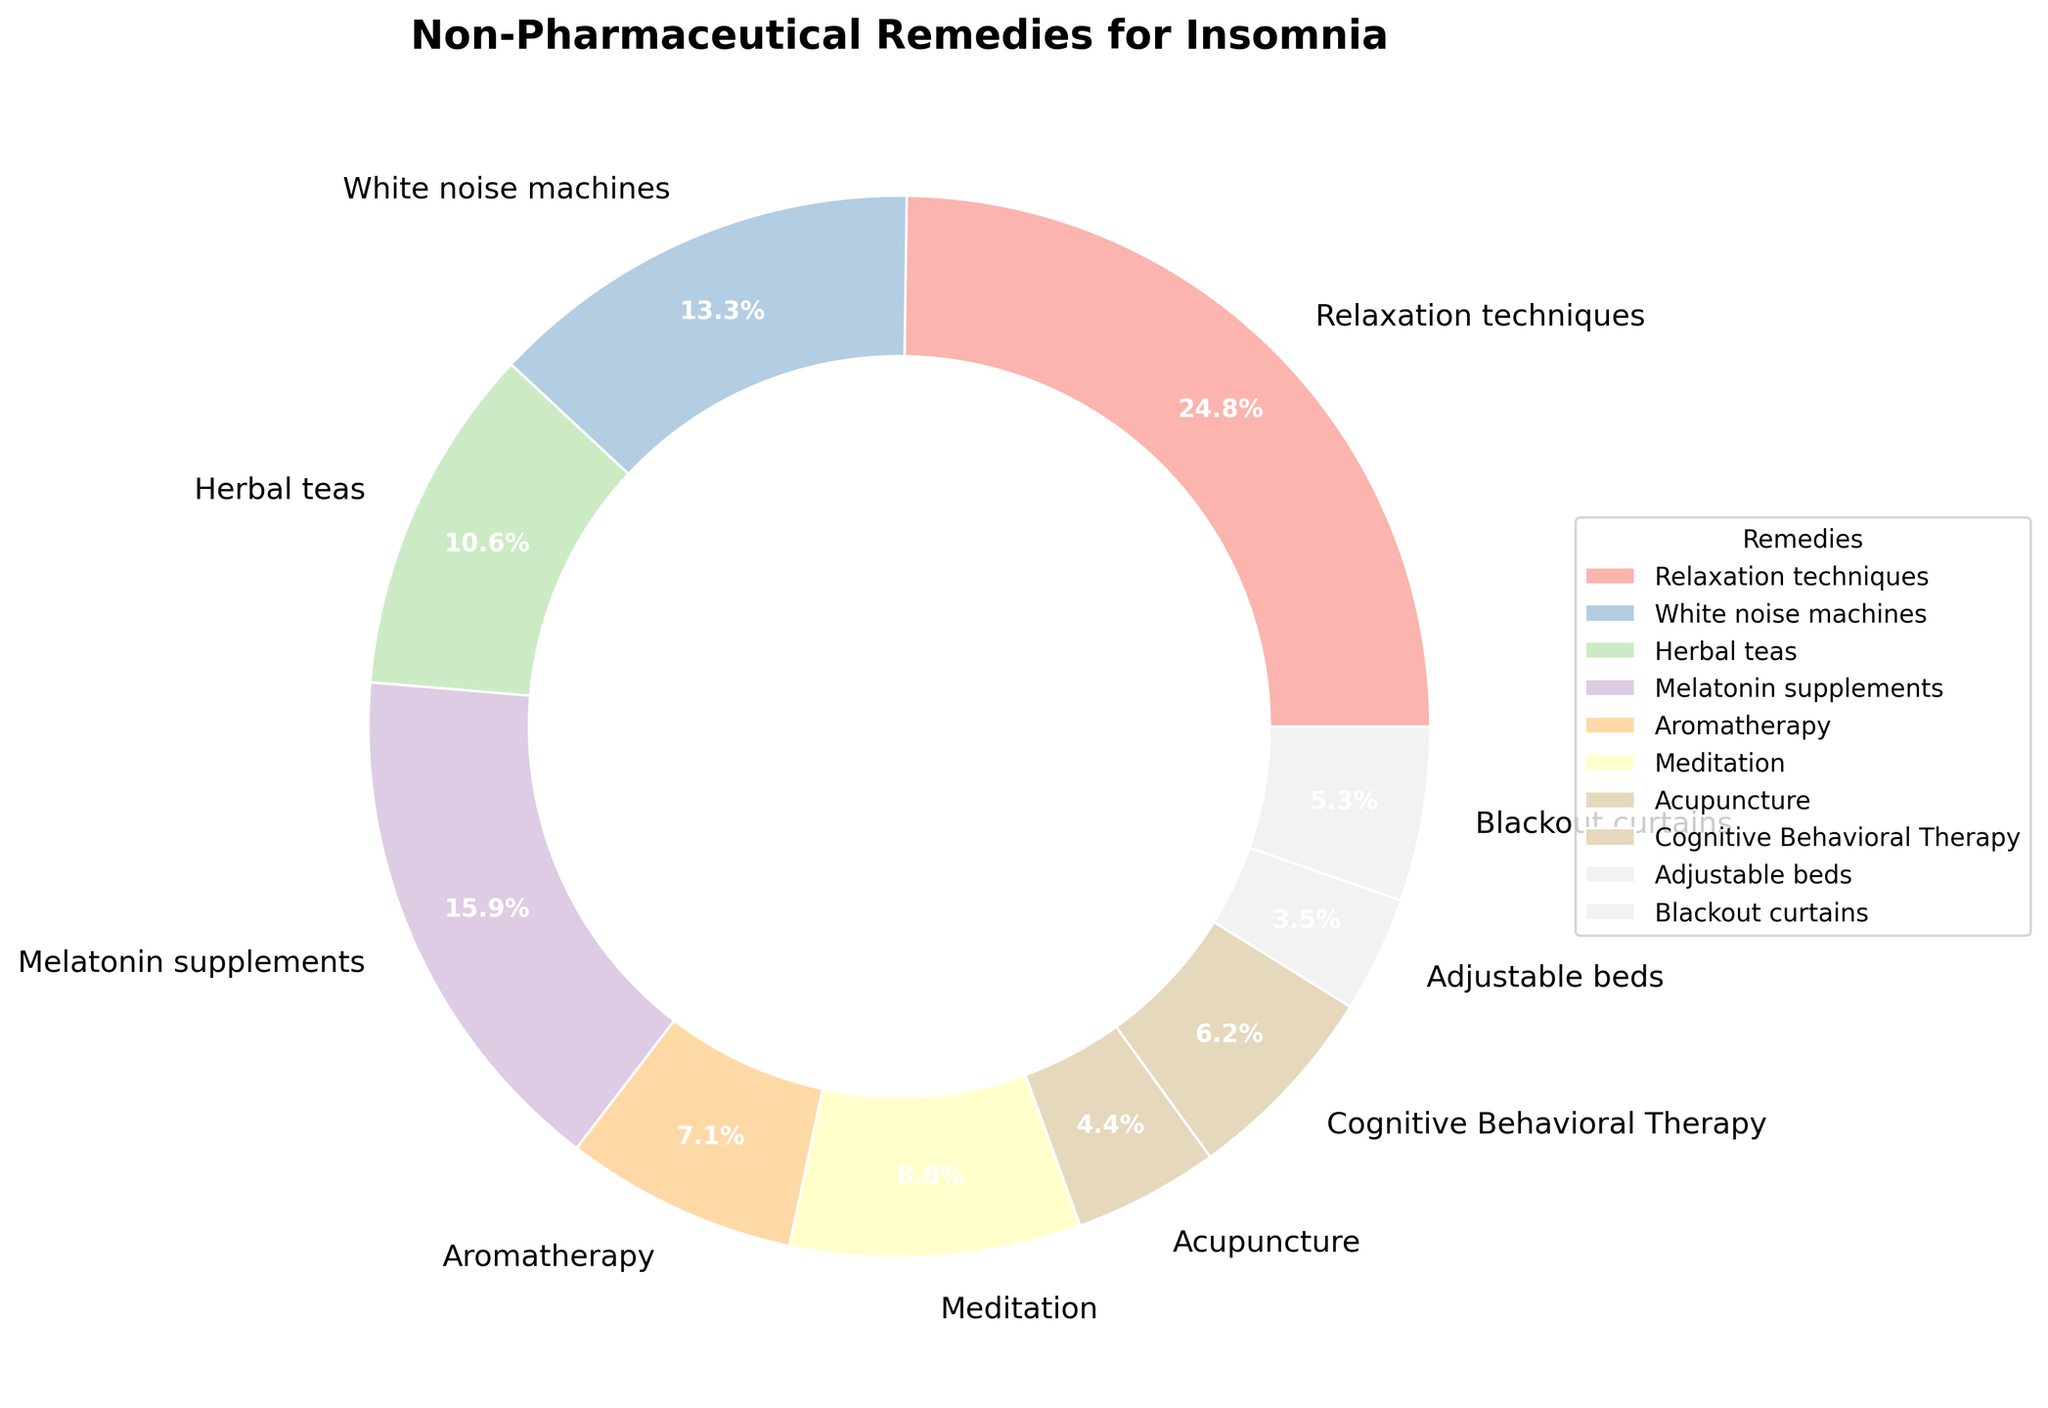What non-pharmaceutical remedy is used by the highest percentage of insomnia sufferers? The pie chart shows the percentage of insomnia sufferers using various remedies. The segment labeled "Relaxation techniques" has the highest percentage at 28%.
Answer: Relaxation techniques Which remedies are used by more than 15% of insomnia sufferers? Checking the pie chart, Relaxation techniques (28%) and Melatonin supplements (18%) are above 15%.
Answer: Relaxation techniques, Melatonin supplements What is the combined percentage of sufferers using Herbal teas, Aromatherapy, and Acupuncture? Sum the percentages for Herbal teas (12%), Aromatherapy (8%), and Acupuncture (5%). 12 + 8 + 5 = 25%
Answer: 25% Are any of the remedies used by the same percentage of insomnia sufferers? The pie chart segments do not show any two remedies with the same percentage. Each remedy has a unique percentage.
Answer: No Compare the use of White noise machines and Meditation. Which one is more popular? Refer to the pie chart. White noise machines are used by 15%, while Meditation is used by 10%. White noise machines have a higher percentage.
Answer: White noise machines Which remedy has the smallest segment in the pie chart? The smallest segment in the pie chart corresponds to Adjustable beds with 4%.
Answer: Adjustable beds Is Cognitive Behavioral Therapy more commonly used than Blackout curtains? Referencing the pie chart, Cognitive Behavioral Therapy is used by 7%, while Blackout curtains are used by 6%. Cognitive Behavioral Therapy has a higher percentage.
Answer: Yes What is the average percentage use of the top three remedies? Identify the top three remedies: Relaxation techniques (28%), Melatonin supplements (18%), and White noise machines (15%). Calculate the average: (28 + 18 + 15) / 3 = 61 / 3 = 20.3%
Answer: 20.3% Which remedy is closest in use percentage to Aromatherapy? Checking the pie chart, Aromatherapy is at 8%. The closest remedies by percentage are Cognitive Behavioral Therapy at 7% and Meditation at 10%.
Answer: Cognitive Behavioral Therapy or Meditation Is there a significant gap between the use of Melatonin supplements and Herbal teas? Melatonin supplements are at 18% and Herbal teas are at 12%. Calculate the difference: 18 - 12 = 6%. This can be considered a moderate gap.
Answer: Yes, a moderate gap 